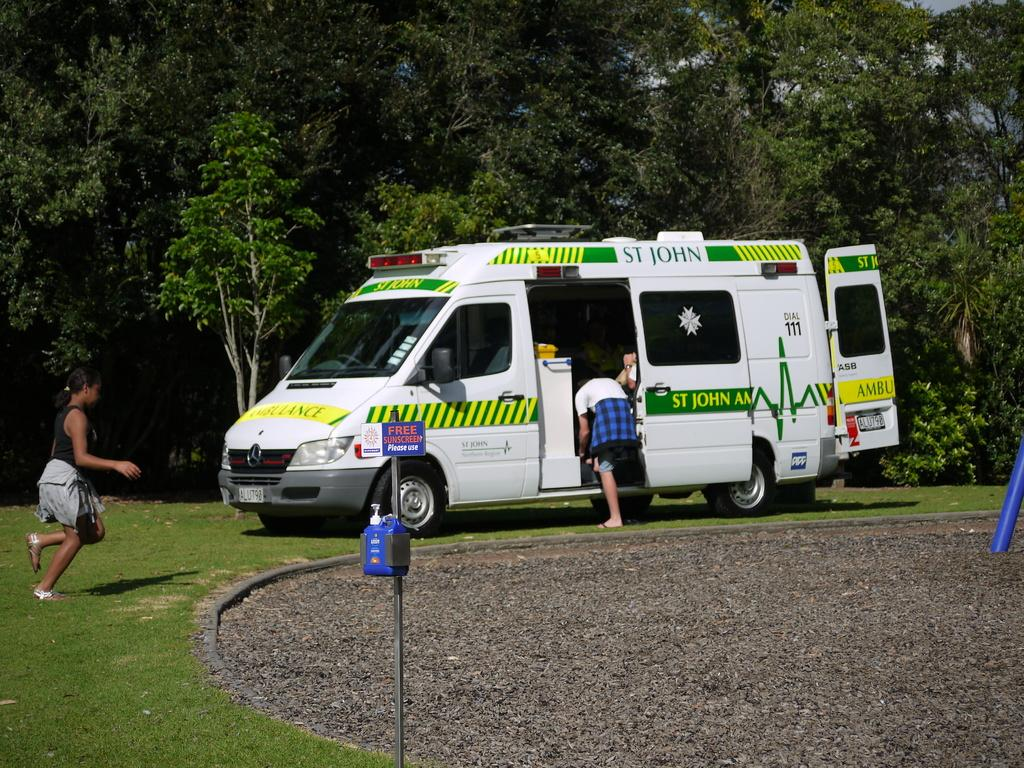What type of vehicle is in the image? There is a van in the image. Where is the van located? The van is on a ground. Who is present on the left side of the image? There is a woman on the left side of the image. What can be seen in the background of the image? There are trees in the background of the image. What type of arch can be seen in the image? There is no arch present in the image. What does the woman's voice sound like in the image? The image does not provide any information about the woman's voice. 